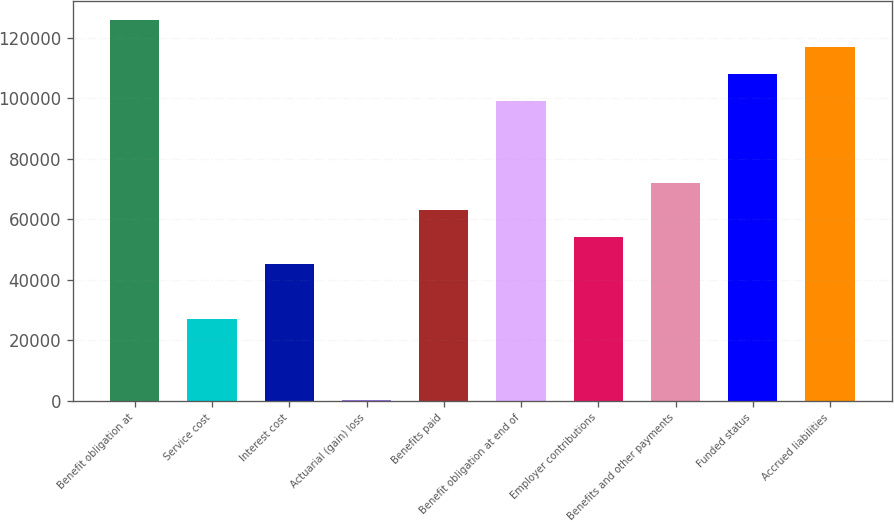Convert chart. <chart><loc_0><loc_0><loc_500><loc_500><bar_chart><fcel>Benefit obligation at<fcel>Service cost<fcel>Interest cost<fcel>Actuarial (gain) loss<fcel>Benefits paid<fcel>Benefit obligation at end of<fcel>Employer contributions<fcel>Benefits and other payments<fcel>Funded status<fcel>Accrued liabilities<nl><fcel>126073<fcel>27158.6<fcel>45143<fcel>182<fcel>63127.4<fcel>99096.2<fcel>54135.2<fcel>72119.6<fcel>108088<fcel>117081<nl></chart> 